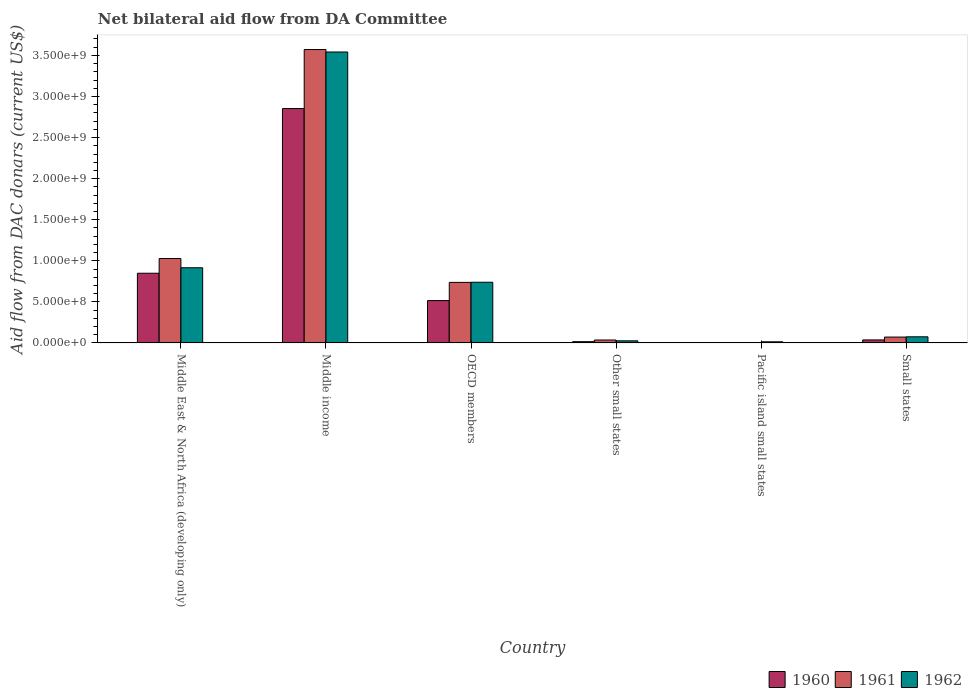How many bars are there on the 1st tick from the left?
Provide a succinct answer. 3. What is the label of the 5th group of bars from the left?
Your answer should be very brief. Pacific island small states. In how many cases, is the number of bars for a given country not equal to the number of legend labels?
Ensure brevity in your answer.  0. What is the aid flow in in 1961 in Small states?
Your response must be concise. 7.15e+07. Across all countries, what is the maximum aid flow in in 1962?
Make the answer very short. 3.54e+09. Across all countries, what is the minimum aid flow in in 1960?
Ensure brevity in your answer.  3.08e+06. In which country was the aid flow in in 1962 minimum?
Your response must be concise. Pacific island small states. What is the total aid flow in in 1961 in the graph?
Make the answer very short. 5.45e+09. What is the difference between the aid flow in in 1960 in Pacific island small states and that in Small states?
Offer a very short reply. -3.36e+07. What is the difference between the aid flow in in 1961 in Small states and the aid flow in in 1962 in Other small states?
Provide a short and direct response. 4.57e+07. What is the average aid flow in in 1962 per country?
Your answer should be compact. 8.85e+08. What is the difference between the aid flow in of/in 1961 and aid flow in of/in 1960 in Other small states?
Offer a very short reply. 2.02e+07. What is the ratio of the aid flow in in 1960 in OECD members to that in Other small states?
Offer a terse response. 33.22. Is the difference between the aid flow in in 1961 in Middle income and Pacific island small states greater than the difference between the aid flow in in 1960 in Middle income and Pacific island small states?
Make the answer very short. Yes. What is the difference between the highest and the second highest aid flow in in 1962?
Make the answer very short. 2.80e+09. What is the difference between the highest and the lowest aid flow in in 1962?
Give a very brief answer. 3.53e+09. In how many countries, is the aid flow in in 1961 greater than the average aid flow in in 1961 taken over all countries?
Give a very brief answer. 2. Is it the case that in every country, the sum of the aid flow in in 1961 and aid flow in in 1960 is greater than the aid flow in in 1962?
Your answer should be compact. No. How many bars are there?
Provide a short and direct response. 18. Are all the bars in the graph horizontal?
Ensure brevity in your answer.  No. How many countries are there in the graph?
Offer a very short reply. 6. What is the difference between two consecutive major ticks on the Y-axis?
Offer a terse response. 5.00e+08. Does the graph contain any zero values?
Provide a succinct answer. No. Where does the legend appear in the graph?
Make the answer very short. Bottom right. How many legend labels are there?
Ensure brevity in your answer.  3. How are the legend labels stacked?
Give a very brief answer. Horizontal. What is the title of the graph?
Give a very brief answer. Net bilateral aid flow from DA Committee. Does "1989" appear as one of the legend labels in the graph?
Your answer should be compact. No. What is the label or title of the X-axis?
Offer a terse response. Country. What is the label or title of the Y-axis?
Keep it short and to the point. Aid flow from DAC donars (current US$). What is the Aid flow from DAC donars (current US$) of 1960 in Middle East & North Africa (developing only)?
Your answer should be very brief. 8.48e+08. What is the Aid flow from DAC donars (current US$) of 1961 in Middle East & North Africa (developing only)?
Your answer should be compact. 1.03e+09. What is the Aid flow from DAC donars (current US$) in 1962 in Middle East & North Africa (developing only)?
Your response must be concise. 9.15e+08. What is the Aid flow from DAC donars (current US$) in 1960 in Middle income?
Your answer should be very brief. 2.85e+09. What is the Aid flow from DAC donars (current US$) in 1961 in Middle income?
Your answer should be very brief. 3.57e+09. What is the Aid flow from DAC donars (current US$) in 1962 in Middle income?
Your answer should be compact. 3.54e+09. What is the Aid flow from DAC donars (current US$) of 1960 in OECD members?
Make the answer very short. 5.16e+08. What is the Aid flow from DAC donars (current US$) in 1961 in OECD members?
Ensure brevity in your answer.  7.37e+08. What is the Aid flow from DAC donars (current US$) in 1962 in OECD members?
Keep it short and to the point. 7.39e+08. What is the Aid flow from DAC donars (current US$) in 1960 in Other small states?
Provide a succinct answer. 1.55e+07. What is the Aid flow from DAC donars (current US$) in 1961 in Other small states?
Keep it short and to the point. 3.57e+07. What is the Aid flow from DAC donars (current US$) in 1962 in Other small states?
Offer a terse response. 2.57e+07. What is the Aid flow from DAC donars (current US$) in 1960 in Pacific island small states?
Make the answer very short. 3.08e+06. What is the Aid flow from DAC donars (current US$) in 1961 in Pacific island small states?
Your answer should be very brief. 3.47e+06. What is the Aid flow from DAC donars (current US$) in 1962 in Pacific island small states?
Offer a very short reply. 1.38e+07. What is the Aid flow from DAC donars (current US$) of 1960 in Small states?
Offer a terse response. 3.66e+07. What is the Aid flow from DAC donars (current US$) of 1961 in Small states?
Provide a short and direct response. 7.15e+07. What is the Aid flow from DAC donars (current US$) in 1962 in Small states?
Offer a very short reply. 7.46e+07. Across all countries, what is the maximum Aid flow from DAC donars (current US$) of 1960?
Offer a very short reply. 2.85e+09. Across all countries, what is the maximum Aid flow from DAC donars (current US$) in 1961?
Your answer should be very brief. 3.57e+09. Across all countries, what is the maximum Aid flow from DAC donars (current US$) of 1962?
Give a very brief answer. 3.54e+09. Across all countries, what is the minimum Aid flow from DAC donars (current US$) of 1960?
Offer a terse response. 3.08e+06. Across all countries, what is the minimum Aid flow from DAC donars (current US$) in 1961?
Offer a terse response. 3.47e+06. Across all countries, what is the minimum Aid flow from DAC donars (current US$) in 1962?
Your answer should be very brief. 1.38e+07. What is the total Aid flow from DAC donars (current US$) of 1960 in the graph?
Keep it short and to the point. 4.27e+09. What is the total Aid flow from DAC donars (current US$) of 1961 in the graph?
Your answer should be compact. 5.45e+09. What is the total Aid flow from DAC donars (current US$) in 1962 in the graph?
Offer a terse response. 5.31e+09. What is the difference between the Aid flow from DAC donars (current US$) of 1960 in Middle East & North Africa (developing only) and that in Middle income?
Offer a very short reply. -2.01e+09. What is the difference between the Aid flow from DAC donars (current US$) of 1961 in Middle East & North Africa (developing only) and that in Middle income?
Ensure brevity in your answer.  -2.54e+09. What is the difference between the Aid flow from DAC donars (current US$) of 1962 in Middle East & North Africa (developing only) and that in Middle income?
Your response must be concise. -2.63e+09. What is the difference between the Aid flow from DAC donars (current US$) in 1960 in Middle East & North Africa (developing only) and that in OECD members?
Your response must be concise. 3.33e+08. What is the difference between the Aid flow from DAC donars (current US$) of 1961 in Middle East & North Africa (developing only) and that in OECD members?
Offer a terse response. 2.90e+08. What is the difference between the Aid flow from DAC donars (current US$) of 1962 in Middle East & North Africa (developing only) and that in OECD members?
Give a very brief answer. 1.76e+08. What is the difference between the Aid flow from DAC donars (current US$) of 1960 in Middle East & North Africa (developing only) and that in Other small states?
Keep it short and to the point. 8.33e+08. What is the difference between the Aid flow from DAC donars (current US$) of 1961 in Middle East & North Africa (developing only) and that in Other small states?
Offer a very short reply. 9.92e+08. What is the difference between the Aid flow from DAC donars (current US$) of 1962 in Middle East & North Africa (developing only) and that in Other small states?
Provide a short and direct response. 8.89e+08. What is the difference between the Aid flow from DAC donars (current US$) in 1960 in Middle East & North Africa (developing only) and that in Pacific island small states?
Your response must be concise. 8.45e+08. What is the difference between the Aid flow from DAC donars (current US$) in 1961 in Middle East & North Africa (developing only) and that in Pacific island small states?
Give a very brief answer. 1.02e+09. What is the difference between the Aid flow from DAC donars (current US$) in 1962 in Middle East & North Africa (developing only) and that in Pacific island small states?
Your response must be concise. 9.01e+08. What is the difference between the Aid flow from DAC donars (current US$) in 1960 in Middle East & North Africa (developing only) and that in Small states?
Your answer should be compact. 8.12e+08. What is the difference between the Aid flow from DAC donars (current US$) in 1961 in Middle East & North Africa (developing only) and that in Small states?
Your answer should be compact. 9.56e+08. What is the difference between the Aid flow from DAC donars (current US$) of 1962 in Middle East & North Africa (developing only) and that in Small states?
Offer a very short reply. 8.40e+08. What is the difference between the Aid flow from DAC donars (current US$) of 1960 in Middle income and that in OECD members?
Make the answer very short. 2.34e+09. What is the difference between the Aid flow from DAC donars (current US$) of 1961 in Middle income and that in OECD members?
Your answer should be compact. 2.83e+09. What is the difference between the Aid flow from DAC donars (current US$) in 1962 in Middle income and that in OECD members?
Make the answer very short. 2.80e+09. What is the difference between the Aid flow from DAC donars (current US$) in 1960 in Middle income and that in Other small states?
Provide a succinct answer. 2.84e+09. What is the difference between the Aid flow from DAC donars (current US$) in 1961 in Middle income and that in Other small states?
Ensure brevity in your answer.  3.54e+09. What is the difference between the Aid flow from DAC donars (current US$) of 1962 in Middle income and that in Other small states?
Your answer should be very brief. 3.52e+09. What is the difference between the Aid flow from DAC donars (current US$) in 1960 in Middle income and that in Pacific island small states?
Provide a succinct answer. 2.85e+09. What is the difference between the Aid flow from DAC donars (current US$) in 1961 in Middle income and that in Pacific island small states?
Offer a terse response. 3.57e+09. What is the difference between the Aid flow from DAC donars (current US$) of 1962 in Middle income and that in Pacific island small states?
Your answer should be compact. 3.53e+09. What is the difference between the Aid flow from DAC donars (current US$) of 1960 in Middle income and that in Small states?
Provide a short and direct response. 2.82e+09. What is the difference between the Aid flow from DAC donars (current US$) in 1961 in Middle income and that in Small states?
Provide a short and direct response. 3.50e+09. What is the difference between the Aid flow from DAC donars (current US$) of 1962 in Middle income and that in Small states?
Provide a short and direct response. 3.47e+09. What is the difference between the Aid flow from DAC donars (current US$) of 1960 in OECD members and that in Other small states?
Ensure brevity in your answer.  5.00e+08. What is the difference between the Aid flow from DAC donars (current US$) in 1961 in OECD members and that in Other small states?
Your answer should be very brief. 7.02e+08. What is the difference between the Aid flow from DAC donars (current US$) in 1962 in OECD members and that in Other small states?
Offer a very short reply. 7.13e+08. What is the difference between the Aid flow from DAC donars (current US$) of 1960 in OECD members and that in Pacific island small states?
Your answer should be very brief. 5.12e+08. What is the difference between the Aid flow from DAC donars (current US$) in 1961 in OECD members and that in Pacific island small states?
Your answer should be very brief. 7.34e+08. What is the difference between the Aid flow from DAC donars (current US$) of 1962 in OECD members and that in Pacific island small states?
Keep it short and to the point. 7.25e+08. What is the difference between the Aid flow from DAC donars (current US$) of 1960 in OECD members and that in Small states?
Make the answer very short. 4.79e+08. What is the difference between the Aid flow from DAC donars (current US$) of 1961 in OECD members and that in Small states?
Your response must be concise. 6.66e+08. What is the difference between the Aid flow from DAC donars (current US$) in 1962 in OECD members and that in Small states?
Keep it short and to the point. 6.64e+08. What is the difference between the Aid flow from DAC donars (current US$) in 1960 in Other small states and that in Pacific island small states?
Provide a succinct answer. 1.24e+07. What is the difference between the Aid flow from DAC donars (current US$) of 1961 in Other small states and that in Pacific island small states?
Offer a very short reply. 3.22e+07. What is the difference between the Aid flow from DAC donars (current US$) of 1962 in Other small states and that in Pacific island small states?
Provide a succinct answer. 1.19e+07. What is the difference between the Aid flow from DAC donars (current US$) of 1960 in Other small states and that in Small states?
Provide a short and direct response. -2.11e+07. What is the difference between the Aid flow from DAC donars (current US$) of 1961 in Other small states and that in Small states?
Make the answer very short. -3.58e+07. What is the difference between the Aid flow from DAC donars (current US$) in 1962 in Other small states and that in Small states?
Make the answer very short. -4.89e+07. What is the difference between the Aid flow from DAC donars (current US$) of 1960 in Pacific island small states and that in Small states?
Your answer should be very brief. -3.36e+07. What is the difference between the Aid flow from DAC donars (current US$) in 1961 in Pacific island small states and that in Small states?
Offer a very short reply. -6.80e+07. What is the difference between the Aid flow from DAC donars (current US$) of 1962 in Pacific island small states and that in Small states?
Offer a very short reply. -6.08e+07. What is the difference between the Aid flow from DAC donars (current US$) in 1960 in Middle East & North Africa (developing only) and the Aid flow from DAC donars (current US$) in 1961 in Middle income?
Make the answer very short. -2.72e+09. What is the difference between the Aid flow from DAC donars (current US$) of 1960 in Middle East & North Africa (developing only) and the Aid flow from DAC donars (current US$) of 1962 in Middle income?
Your response must be concise. -2.69e+09. What is the difference between the Aid flow from DAC donars (current US$) in 1961 in Middle East & North Africa (developing only) and the Aid flow from DAC donars (current US$) in 1962 in Middle income?
Your answer should be very brief. -2.51e+09. What is the difference between the Aid flow from DAC donars (current US$) in 1960 in Middle East & North Africa (developing only) and the Aid flow from DAC donars (current US$) in 1961 in OECD members?
Ensure brevity in your answer.  1.11e+08. What is the difference between the Aid flow from DAC donars (current US$) in 1960 in Middle East & North Africa (developing only) and the Aid flow from DAC donars (current US$) in 1962 in OECD members?
Your answer should be compact. 1.10e+08. What is the difference between the Aid flow from DAC donars (current US$) in 1961 in Middle East & North Africa (developing only) and the Aid flow from DAC donars (current US$) in 1962 in OECD members?
Provide a short and direct response. 2.88e+08. What is the difference between the Aid flow from DAC donars (current US$) of 1960 in Middle East & North Africa (developing only) and the Aid flow from DAC donars (current US$) of 1961 in Other small states?
Make the answer very short. 8.13e+08. What is the difference between the Aid flow from DAC donars (current US$) in 1960 in Middle East & North Africa (developing only) and the Aid flow from DAC donars (current US$) in 1962 in Other small states?
Your answer should be compact. 8.23e+08. What is the difference between the Aid flow from DAC donars (current US$) in 1961 in Middle East & North Africa (developing only) and the Aid flow from DAC donars (current US$) in 1962 in Other small states?
Give a very brief answer. 1.00e+09. What is the difference between the Aid flow from DAC donars (current US$) in 1960 in Middle East & North Africa (developing only) and the Aid flow from DAC donars (current US$) in 1961 in Pacific island small states?
Keep it short and to the point. 8.45e+08. What is the difference between the Aid flow from DAC donars (current US$) in 1960 in Middle East & North Africa (developing only) and the Aid flow from DAC donars (current US$) in 1962 in Pacific island small states?
Provide a short and direct response. 8.35e+08. What is the difference between the Aid flow from DAC donars (current US$) of 1961 in Middle East & North Africa (developing only) and the Aid flow from DAC donars (current US$) of 1962 in Pacific island small states?
Provide a succinct answer. 1.01e+09. What is the difference between the Aid flow from DAC donars (current US$) in 1960 in Middle East & North Africa (developing only) and the Aid flow from DAC donars (current US$) in 1961 in Small states?
Your answer should be compact. 7.77e+08. What is the difference between the Aid flow from DAC donars (current US$) in 1960 in Middle East & North Africa (developing only) and the Aid flow from DAC donars (current US$) in 1962 in Small states?
Provide a short and direct response. 7.74e+08. What is the difference between the Aid flow from DAC donars (current US$) in 1961 in Middle East & North Africa (developing only) and the Aid flow from DAC donars (current US$) in 1962 in Small states?
Ensure brevity in your answer.  9.53e+08. What is the difference between the Aid flow from DAC donars (current US$) of 1960 in Middle income and the Aid flow from DAC donars (current US$) of 1961 in OECD members?
Keep it short and to the point. 2.12e+09. What is the difference between the Aid flow from DAC donars (current US$) in 1960 in Middle income and the Aid flow from DAC donars (current US$) in 1962 in OECD members?
Ensure brevity in your answer.  2.11e+09. What is the difference between the Aid flow from DAC donars (current US$) of 1961 in Middle income and the Aid flow from DAC donars (current US$) of 1962 in OECD members?
Provide a short and direct response. 2.83e+09. What is the difference between the Aid flow from DAC donars (current US$) of 1960 in Middle income and the Aid flow from DAC donars (current US$) of 1961 in Other small states?
Make the answer very short. 2.82e+09. What is the difference between the Aid flow from DAC donars (current US$) in 1960 in Middle income and the Aid flow from DAC donars (current US$) in 1962 in Other small states?
Your answer should be very brief. 2.83e+09. What is the difference between the Aid flow from DAC donars (current US$) of 1961 in Middle income and the Aid flow from DAC donars (current US$) of 1962 in Other small states?
Provide a succinct answer. 3.55e+09. What is the difference between the Aid flow from DAC donars (current US$) of 1960 in Middle income and the Aid flow from DAC donars (current US$) of 1961 in Pacific island small states?
Your response must be concise. 2.85e+09. What is the difference between the Aid flow from DAC donars (current US$) in 1960 in Middle income and the Aid flow from DAC donars (current US$) in 1962 in Pacific island small states?
Keep it short and to the point. 2.84e+09. What is the difference between the Aid flow from DAC donars (current US$) in 1961 in Middle income and the Aid flow from DAC donars (current US$) in 1962 in Pacific island small states?
Your answer should be compact. 3.56e+09. What is the difference between the Aid flow from DAC donars (current US$) in 1960 in Middle income and the Aid flow from DAC donars (current US$) in 1961 in Small states?
Provide a succinct answer. 2.78e+09. What is the difference between the Aid flow from DAC donars (current US$) in 1960 in Middle income and the Aid flow from DAC donars (current US$) in 1962 in Small states?
Your answer should be compact. 2.78e+09. What is the difference between the Aid flow from DAC donars (current US$) in 1961 in Middle income and the Aid flow from DAC donars (current US$) in 1962 in Small states?
Offer a very short reply. 3.50e+09. What is the difference between the Aid flow from DAC donars (current US$) of 1960 in OECD members and the Aid flow from DAC donars (current US$) of 1961 in Other small states?
Your response must be concise. 4.80e+08. What is the difference between the Aid flow from DAC donars (current US$) in 1960 in OECD members and the Aid flow from DAC donars (current US$) in 1962 in Other small states?
Offer a very short reply. 4.90e+08. What is the difference between the Aid flow from DAC donars (current US$) of 1961 in OECD members and the Aid flow from DAC donars (current US$) of 1962 in Other small states?
Your response must be concise. 7.11e+08. What is the difference between the Aid flow from DAC donars (current US$) in 1960 in OECD members and the Aid flow from DAC donars (current US$) in 1961 in Pacific island small states?
Your answer should be very brief. 5.12e+08. What is the difference between the Aid flow from DAC donars (current US$) in 1960 in OECD members and the Aid flow from DAC donars (current US$) in 1962 in Pacific island small states?
Make the answer very short. 5.02e+08. What is the difference between the Aid flow from DAC donars (current US$) of 1961 in OECD members and the Aid flow from DAC donars (current US$) of 1962 in Pacific island small states?
Offer a very short reply. 7.23e+08. What is the difference between the Aid flow from DAC donars (current US$) of 1960 in OECD members and the Aid flow from DAC donars (current US$) of 1961 in Small states?
Make the answer very short. 4.44e+08. What is the difference between the Aid flow from DAC donars (current US$) in 1960 in OECD members and the Aid flow from DAC donars (current US$) in 1962 in Small states?
Offer a very short reply. 4.41e+08. What is the difference between the Aid flow from DAC donars (current US$) of 1961 in OECD members and the Aid flow from DAC donars (current US$) of 1962 in Small states?
Provide a short and direct response. 6.63e+08. What is the difference between the Aid flow from DAC donars (current US$) in 1960 in Other small states and the Aid flow from DAC donars (current US$) in 1961 in Pacific island small states?
Offer a terse response. 1.20e+07. What is the difference between the Aid flow from DAC donars (current US$) in 1960 in Other small states and the Aid flow from DAC donars (current US$) in 1962 in Pacific island small states?
Keep it short and to the point. 1.74e+06. What is the difference between the Aid flow from DAC donars (current US$) of 1961 in Other small states and the Aid flow from DAC donars (current US$) of 1962 in Pacific island small states?
Provide a succinct answer. 2.19e+07. What is the difference between the Aid flow from DAC donars (current US$) in 1960 in Other small states and the Aid flow from DAC donars (current US$) in 1961 in Small states?
Your answer should be very brief. -5.59e+07. What is the difference between the Aid flow from DAC donars (current US$) in 1960 in Other small states and the Aid flow from DAC donars (current US$) in 1962 in Small states?
Ensure brevity in your answer.  -5.91e+07. What is the difference between the Aid flow from DAC donars (current US$) of 1961 in Other small states and the Aid flow from DAC donars (current US$) of 1962 in Small states?
Make the answer very short. -3.90e+07. What is the difference between the Aid flow from DAC donars (current US$) in 1960 in Pacific island small states and the Aid flow from DAC donars (current US$) in 1961 in Small states?
Make the answer very short. -6.84e+07. What is the difference between the Aid flow from DAC donars (current US$) of 1960 in Pacific island small states and the Aid flow from DAC donars (current US$) of 1962 in Small states?
Provide a succinct answer. -7.16e+07. What is the difference between the Aid flow from DAC donars (current US$) of 1961 in Pacific island small states and the Aid flow from DAC donars (current US$) of 1962 in Small states?
Offer a very short reply. -7.12e+07. What is the average Aid flow from DAC donars (current US$) of 1960 per country?
Provide a short and direct response. 7.12e+08. What is the average Aid flow from DAC donars (current US$) of 1961 per country?
Offer a very short reply. 9.08e+08. What is the average Aid flow from DAC donars (current US$) of 1962 per country?
Keep it short and to the point. 8.85e+08. What is the difference between the Aid flow from DAC donars (current US$) in 1960 and Aid flow from DAC donars (current US$) in 1961 in Middle East & North Africa (developing only)?
Give a very brief answer. -1.79e+08. What is the difference between the Aid flow from DAC donars (current US$) in 1960 and Aid flow from DAC donars (current US$) in 1962 in Middle East & North Africa (developing only)?
Offer a terse response. -6.67e+07. What is the difference between the Aid flow from DAC donars (current US$) in 1961 and Aid flow from DAC donars (current US$) in 1962 in Middle East & North Africa (developing only)?
Your answer should be compact. 1.12e+08. What is the difference between the Aid flow from DAC donars (current US$) in 1960 and Aid flow from DAC donars (current US$) in 1961 in Middle income?
Offer a terse response. -7.18e+08. What is the difference between the Aid flow from DAC donars (current US$) of 1960 and Aid flow from DAC donars (current US$) of 1962 in Middle income?
Provide a short and direct response. -6.88e+08. What is the difference between the Aid flow from DAC donars (current US$) of 1961 and Aid flow from DAC donars (current US$) of 1962 in Middle income?
Your response must be concise. 2.98e+07. What is the difference between the Aid flow from DAC donars (current US$) of 1960 and Aid flow from DAC donars (current US$) of 1961 in OECD members?
Ensure brevity in your answer.  -2.22e+08. What is the difference between the Aid flow from DAC donars (current US$) of 1960 and Aid flow from DAC donars (current US$) of 1962 in OECD members?
Offer a terse response. -2.23e+08. What is the difference between the Aid flow from DAC donars (current US$) of 1961 and Aid flow from DAC donars (current US$) of 1962 in OECD members?
Ensure brevity in your answer.  -1.69e+06. What is the difference between the Aid flow from DAC donars (current US$) in 1960 and Aid flow from DAC donars (current US$) in 1961 in Other small states?
Ensure brevity in your answer.  -2.02e+07. What is the difference between the Aid flow from DAC donars (current US$) in 1960 and Aid flow from DAC donars (current US$) in 1962 in Other small states?
Your answer should be compact. -1.02e+07. What is the difference between the Aid flow from DAC donars (current US$) in 1961 and Aid flow from DAC donars (current US$) in 1962 in Other small states?
Offer a terse response. 9.95e+06. What is the difference between the Aid flow from DAC donars (current US$) of 1960 and Aid flow from DAC donars (current US$) of 1961 in Pacific island small states?
Give a very brief answer. -3.90e+05. What is the difference between the Aid flow from DAC donars (current US$) of 1960 and Aid flow from DAC donars (current US$) of 1962 in Pacific island small states?
Provide a succinct answer. -1.07e+07. What is the difference between the Aid flow from DAC donars (current US$) in 1961 and Aid flow from DAC donars (current US$) in 1962 in Pacific island small states?
Make the answer very short. -1.03e+07. What is the difference between the Aid flow from DAC donars (current US$) of 1960 and Aid flow from DAC donars (current US$) of 1961 in Small states?
Make the answer very short. -3.48e+07. What is the difference between the Aid flow from DAC donars (current US$) of 1960 and Aid flow from DAC donars (current US$) of 1962 in Small states?
Keep it short and to the point. -3.80e+07. What is the difference between the Aid flow from DAC donars (current US$) in 1961 and Aid flow from DAC donars (current US$) in 1962 in Small states?
Keep it short and to the point. -3.17e+06. What is the ratio of the Aid flow from DAC donars (current US$) of 1960 in Middle East & North Africa (developing only) to that in Middle income?
Offer a terse response. 0.3. What is the ratio of the Aid flow from DAC donars (current US$) in 1961 in Middle East & North Africa (developing only) to that in Middle income?
Ensure brevity in your answer.  0.29. What is the ratio of the Aid flow from DAC donars (current US$) of 1962 in Middle East & North Africa (developing only) to that in Middle income?
Ensure brevity in your answer.  0.26. What is the ratio of the Aid flow from DAC donars (current US$) in 1960 in Middle East & North Africa (developing only) to that in OECD members?
Provide a succinct answer. 1.65. What is the ratio of the Aid flow from DAC donars (current US$) in 1961 in Middle East & North Africa (developing only) to that in OECD members?
Give a very brief answer. 1.39. What is the ratio of the Aid flow from DAC donars (current US$) in 1962 in Middle East & North Africa (developing only) to that in OECD members?
Your response must be concise. 1.24. What is the ratio of the Aid flow from DAC donars (current US$) of 1960 in Middle East & North Africa (developing only) to that in Other small states?
Your answer should be compact. 54.67. What is the ratio of the Aid flow from DAC donars (current US$) of 1961 in Middle East & North Africa (developing only) to that in Other small states?
Offer a terse response. 28.8. What is the ratio of the Aid flow from DAC donars (current US$) in 1962 in Middle East & North Africa (developing only) to that in Other small states?
Provide a succinct answer. 35.58. What is the ratio of the Aid flow from DAC donars (current US$) of 1960 in Middle East & North Africa (developing only) to that in Pacific island small states?
Offer a terse response. 275.46. What is the ratio of the Aid flow from DAC donars (current US$) in 1961 in Middle East & North Africa (developing only) to that in Pacific island small states?
Offer a terse response. 296.07. What is the ratio of the Aid flow from DAC donars (current US$) in 1962 in Middle East & North Africa (developing only) to that in Pacific island small states?
Offer a very short reply. 66.41. What is the ratio of the Aid flow from DAC donars (current US$) in 1960 in Middle East & North Africa (developing only) to that in Small states?
Keep it short and to the point. 23.16. What is the ratio of the Aid flow from DAC donars (current US$) in 1961 in Middle East & North Africa (developing only) to that in Small states?
Provide a short and direct response. 14.38. What is the ratio of the Aid flow from DAC donars (current US$) in 1962 in Middle East & North Africa (developing only) to that in Small states?
Your answer should be compact. 12.26. What is the ratio of the Aid flow from DAC donars (current US$) of 1960 in Middle income to that in OECD members?
Offer a very short reply. 5.53. What is the ratio of the Aid flow from DAC donars (current US$) in 1961 in Middle income to that in OECD members?
Your answer should be compact. 4.84. What is the ratio of the Aid flow from DAC donars (current US$) in 1962 in Middle income to that in OECD members?
Your response must be concise. 4.79. What is the ratio of the Aid flow from DAC donars (current US$) of 1960 in Middle income to that in Other small states?
Provide a short and direct response. 183.86. What is the ratio of the Aid flow from DAC donars (current US$) in 1961 in Middle income to that in Other small states?
Provide a succinct answer. 100.13. What is the ratio of the Aid flow from DAC donars (current US$) in 1962 in Middle income to that in Other small states?
Your answer should be very brief. 137.7. What is the ratio of the Aid flow from DAC donars (current US$) in 1960 in Middle income to that in Pacific island small states?
Offer a terse response. 926.44. What is the ratio of the Aid flow from DAC donars (current US$) of 1961 in Middle income to that in Pacific island small states?
Your answer should be compact. 1029.27. What is the ratio of the Aid flow from DAC donars (current US$) in 1962 in Middle income to that in Pacific island small states?
Offer a terse response. 257.02. What is the ratio of the Aid flow from DAC donars (current US$) of 1960 in Middle income to that in Small states?
Ensure brevity in your answer.  77.9. What is the ratio of the Aid flow from DAC donars (current US$) of 1961 in Middle income to that in Small states?
Give a very brief answer. 49.98. What is the ratio of the Aid flow from DAC donars (current US$) of 1962 in Middle income to that in Small states?
Provide a short and direct response. 47.46. What is the ratio of the Aid flow from DAC donars (current US$) of 1960 in OECD members to that in Other small states?
Keep it short and to the point. 33.22. What is the ratio of the Aid flow from DAC donars (current US$) of 1961 in OECD members to that in Other small states?
Your response must be concise. 20.67. What is the ratio of the Aid flow from DAC donars (current US$) in 1962 in OECD members to that in Other small states?
Offer a very short reply. 28.73. What is the ratio of the Aid flow from DAC donars (current US$) in 1960 in OECD members to that in Pacific island small states?
Give a very brief answer. 167.39. What is the ratio of the Aid flow from DAC donars (current US$) in 1961 in OECD members to that in Pacific island small states?
Give a very brief answer. 212.45. What is the ratio of the Aid flow from DAC donars (current US$) in 1962 in OECD members to that in Pacific island small states?
Provide a short and direct response. 53.62. What is the ratio of the Aid flow from DAC donars (current US$) of 1960 in OECD members to that in Small states?
Give a very brief answer. 14.07. What is the ratio of the Aid flow from DAC donars (current US$) of 1961 in OECD members to that in Small states?
Provide a short and direct response. 10.32. What is the ratio of the Aid flow from DAC donars (current US$) in 1962 in OECD members to that in Small states?
Your answer should be very brief. 9.9. What is the ratio of the Aid flow from DAC donars (current US$) in 1960 in Other small states to that in Pacific island small states?
Your answer should be very brief. 5.04. What is the ratio of the Aid flow from DAC donars (current US$) in 1961 in Other small states to that in Pacific island small states?
Your answer should be compact. 10.28. What is the ratio of the Aid flow from DAC donars (current US$) of 1962 in Other small states to that in Pacific island small states?
Provide a short and direct response. 1.87. What is the ratio of the Aid flow from DAC donars (current US$) in 1960 in Other small states to that in Small states?
Offer a terse response. 0.42. What is the ratio of the Aid flow from DAC donars (current US$) in 1961 in Other small states to that in Small states?
Make the answer very short. 0.5. What is the ratio of the Aid flow from DAC donars (current US$) in 1962 in Other small states to that in Small states?
Provide a succinct answer. 0.34. What is the ratio of the Aid flow from DAC donars (current US$) of 1960 in Pacific island small states to that in Small states?
Give a very brief answer. 0.08. What is the ratio of the Aid flow from DAC donars (current US$) of 1961 in Pacific island small states to that in Small states?
Provide a succinct answer. 0.05. What is the ratio of the Aid flow from DAC donars (current US$) in 1962 in Pacific island small states to that in Small states?
Offer a very short reply. 0.18. What is the difference between the highest and the second highest Aid flow from DAC donars (current US$) in 1960?
Offer a terse response. 2.01e+09. What is the difference between the highest and the second highest Aid flow from DAC donars (current US$) in 1961?
Your answer should be very brief. 2.54e+09. What is the difference between the highest and the second highest Aid flow from DAC donars (current US$) of 1962?
Offer a terse response. 2.63e+09. What is the difference between the highest and the lowest Aid flow from DAC donars (current US$) of 1960?
Offer a very short reply. 2.85e+09. What is the difference between the highest and the lowest Aid flow from DAC donars (current US$) of 1961?
Your answer should be compact. 3.57e+09. What is the difference between the highest and the lowest Aid flow from DAC donars (current US$) of 1962?
Ensure brevity in your answer.  3.53e+09. 